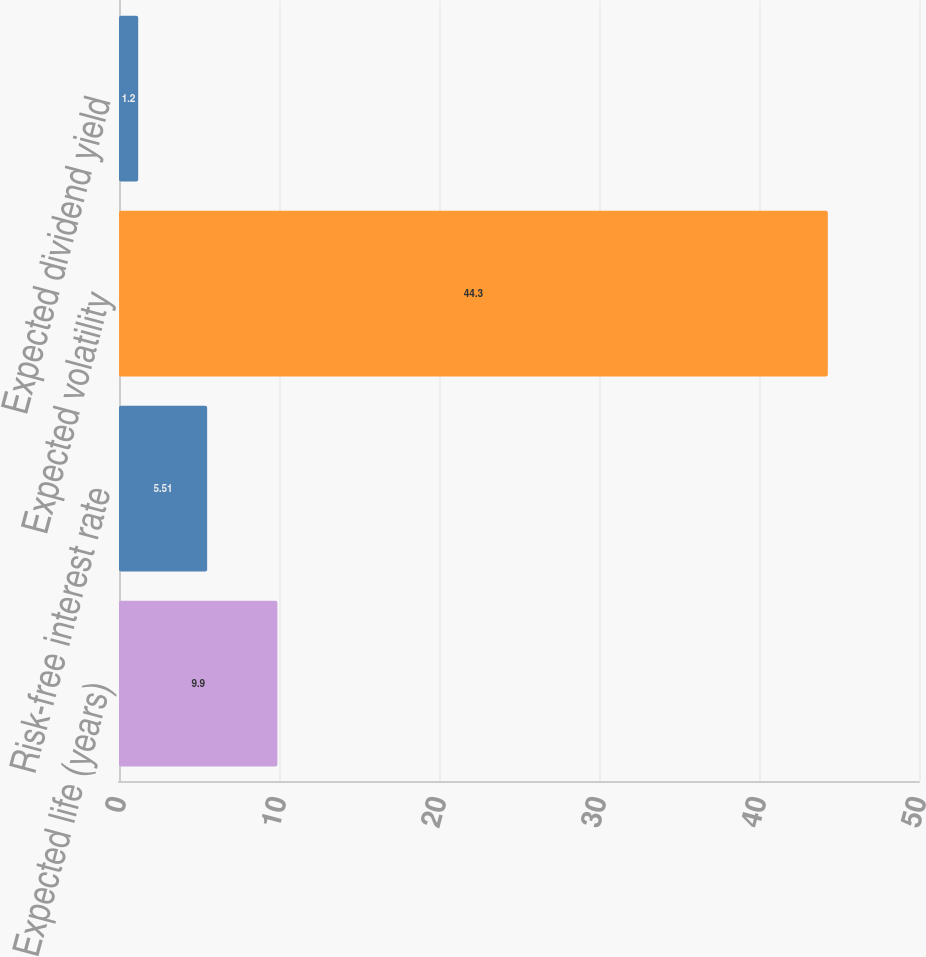Convert chart. <chart><loc_0><loc_0><loc_500><loc_500><bar_chart><fcel>Expected life (years)<fcel>Risk-free interest rate<fcel>Expected volatility<fcel>Expected dividend yield<nl><fcel>9.9<fcel>5.51<fcel>44.3<fcel>1.2<nl></chart> 